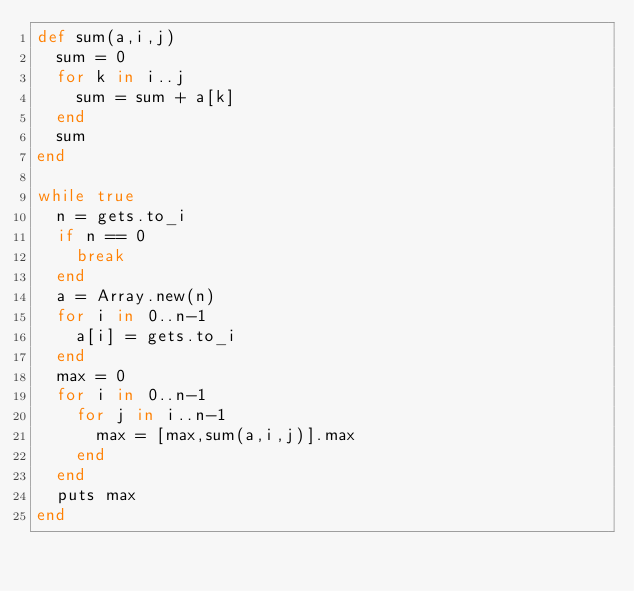<code> <loc_0><loc_0><loc_500><loc_500><_Ruby_>def sum(a,i,j)
  sum = 0
  for k in i..j
    sum = sum + a[k]
  end
  sum
end

while true
  n = gets.to_i
  if n == 0
    break
  end
  a = Array.new(n)
  for i in 0..n-1
    a[i] = gets.to_i
  end
  max = 0
  for i in 0..n-1
    for j in i..n-1
      max = [max,sum(a,i,j)].max
    end
  end
  puts max
end</code> 